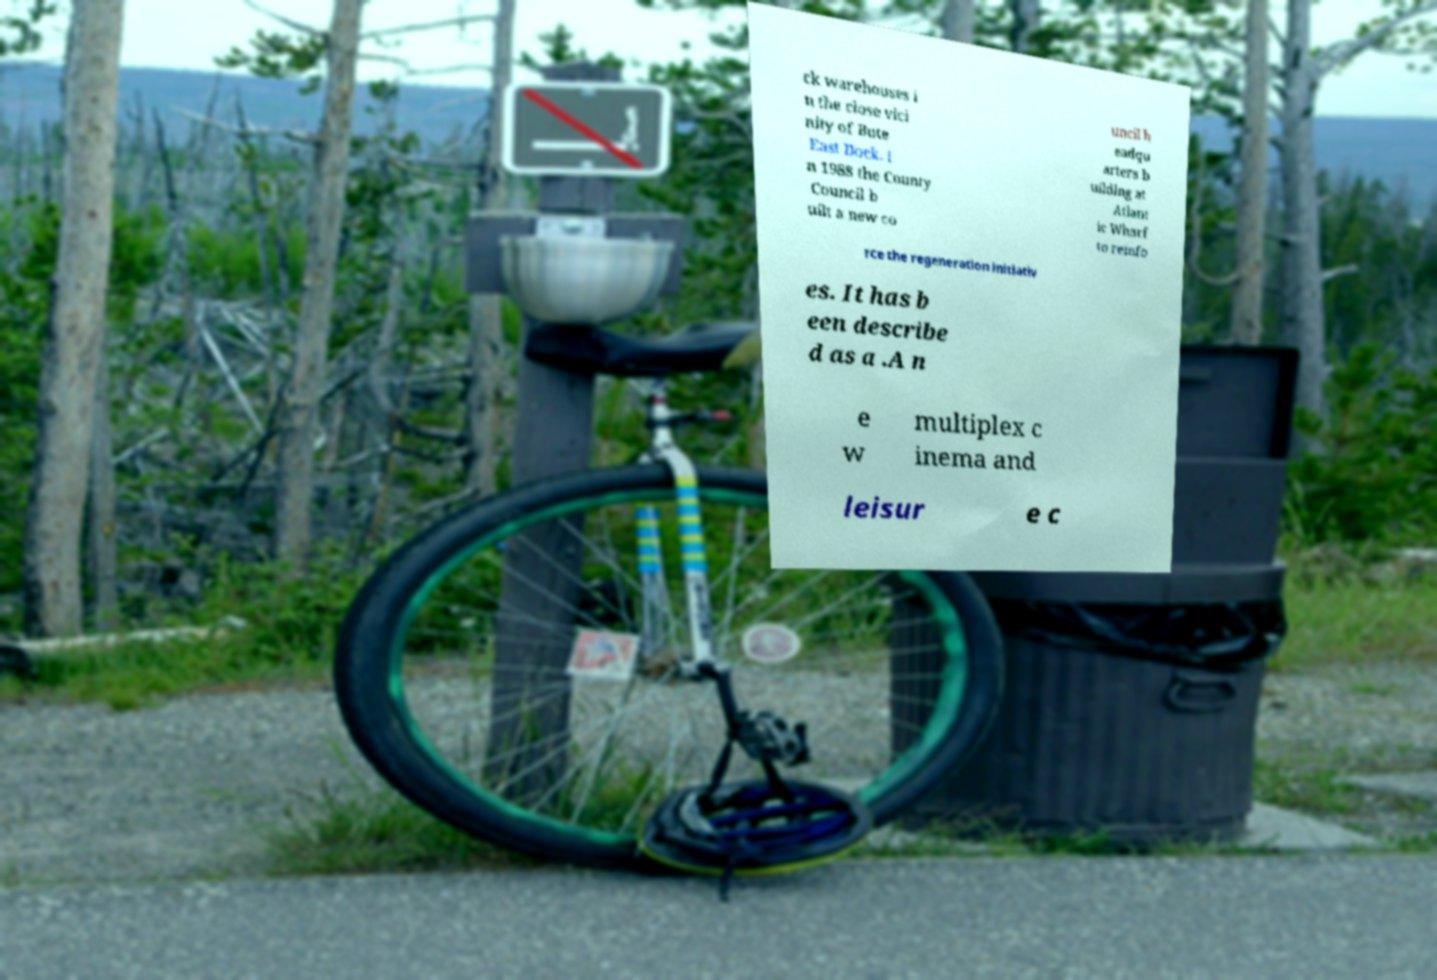Can you read and provide the text displayed in the image?This photo seems to have some interesting text. Can you extract and type it out for me? ck warehouses i n the close vici nity of Bute East Dock. I n 1988 the County Council b uilt a new co uncil h eadqu arters b uilding at Atlant ic Wharf to reinfo rce the regeneration initiativ es. It has b een describe d as a .A n e w multiplex c inema and leisur e c 